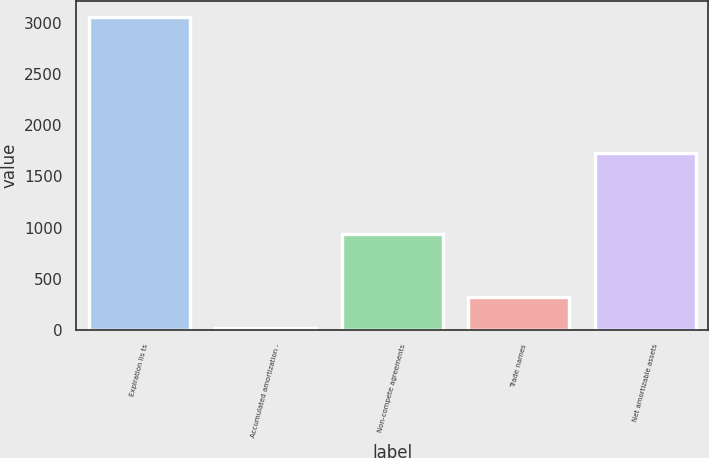<chart> <loc_0><loc_0><loc_500><loc_500><bar_chart><fcel>Expiration lis ts<fcel>Accumulated amortization -<fcel>Non-compete agreements<fcel>Trade names<fcel>Net amortizable assets<nl><fcel>3055.9<fcel>22.5<fcel>932.52<fcel>325.84<fcel>1725.44<nl></chart> 